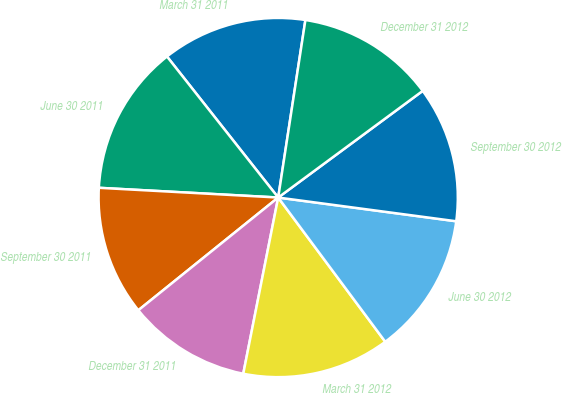<chart> <loc_0><loc_0><loc_500><loc_500><pie_chart><fcel>March 31 2011<fcel>June 30 2011<fcel>September 30 2011<fcel>December 31 2011<fcel>March 31 2012<fcel>June 30 2012<fcel>September 30 2012<fcel>December 31 2012<nl><fcel>13.05%<fcel>13.51%<fcel>11.66%<fcel>11.09%<fcel>13.28%<fcel>12.73%<fcel>12.23%<fcel>12.46%<nl></chart> 